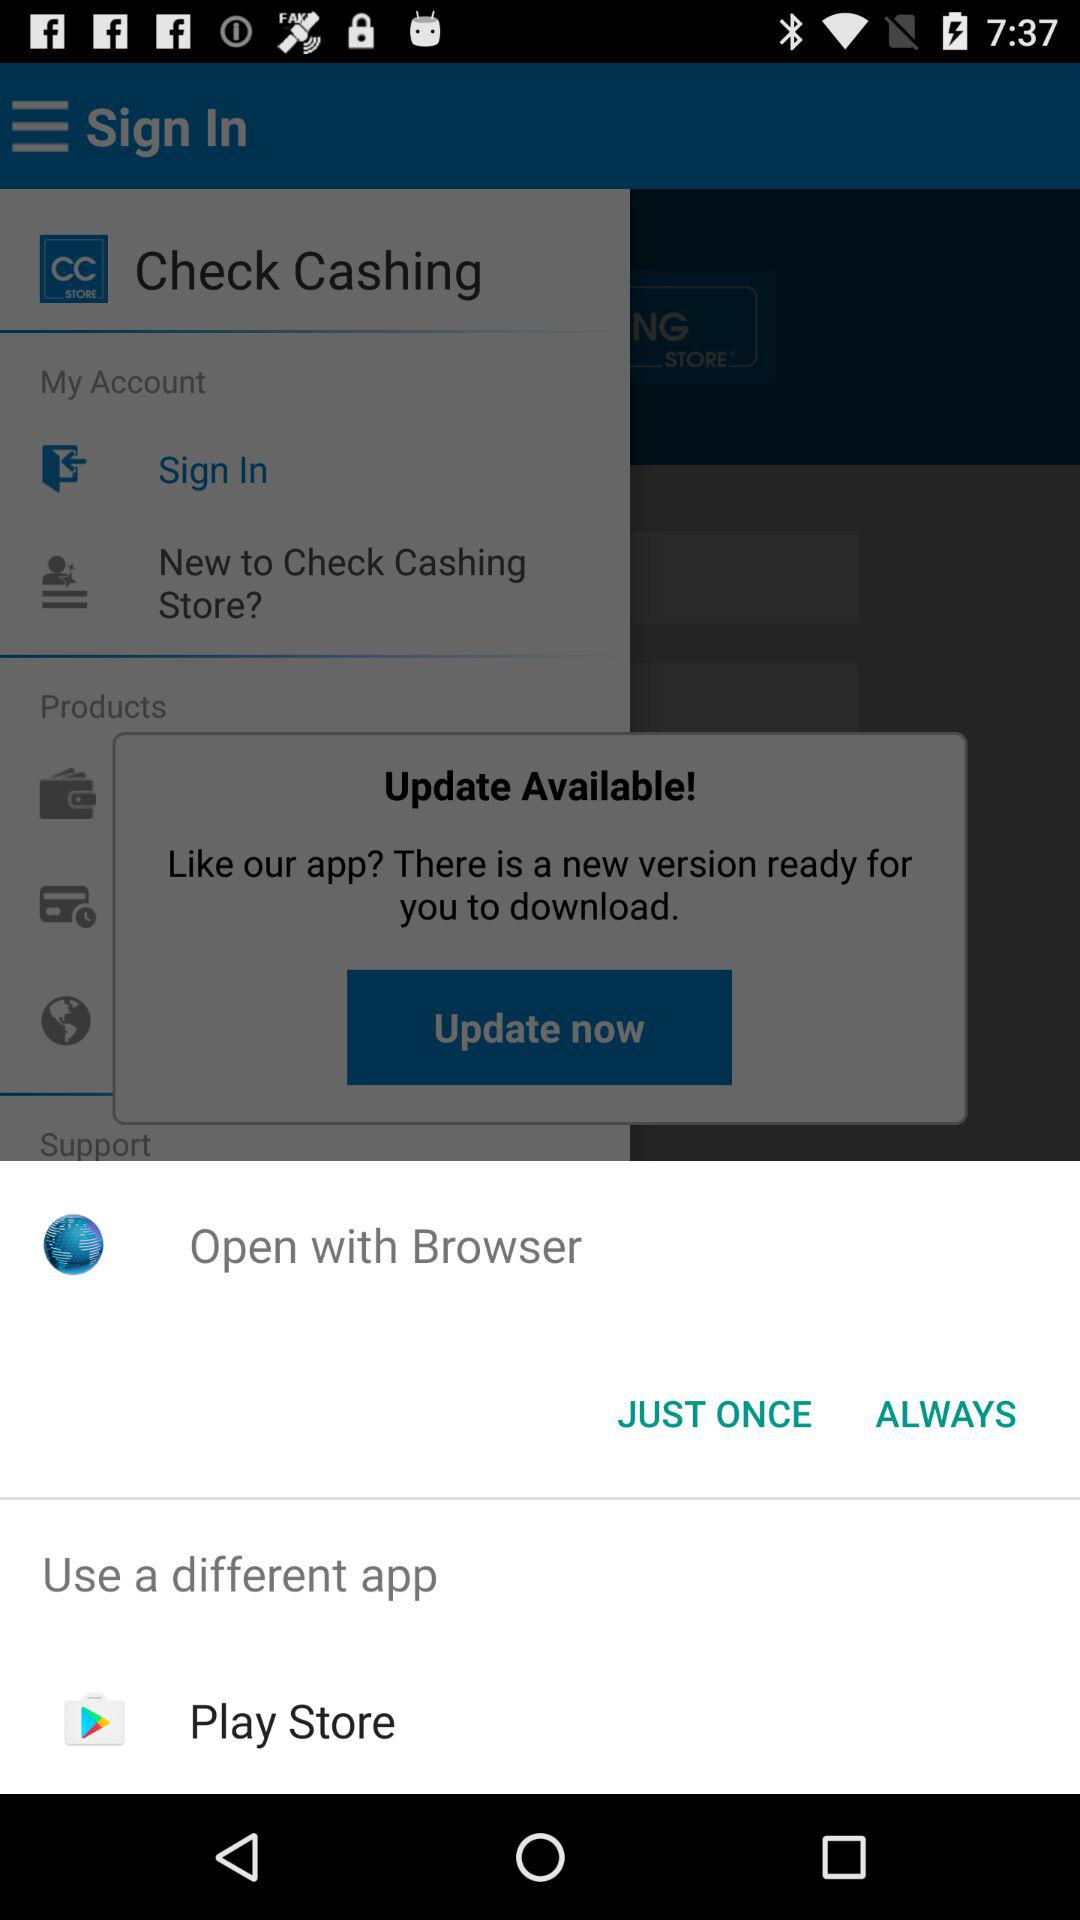What are the applications that can be used to open with? You can open with "Browser" and "Play Store". 